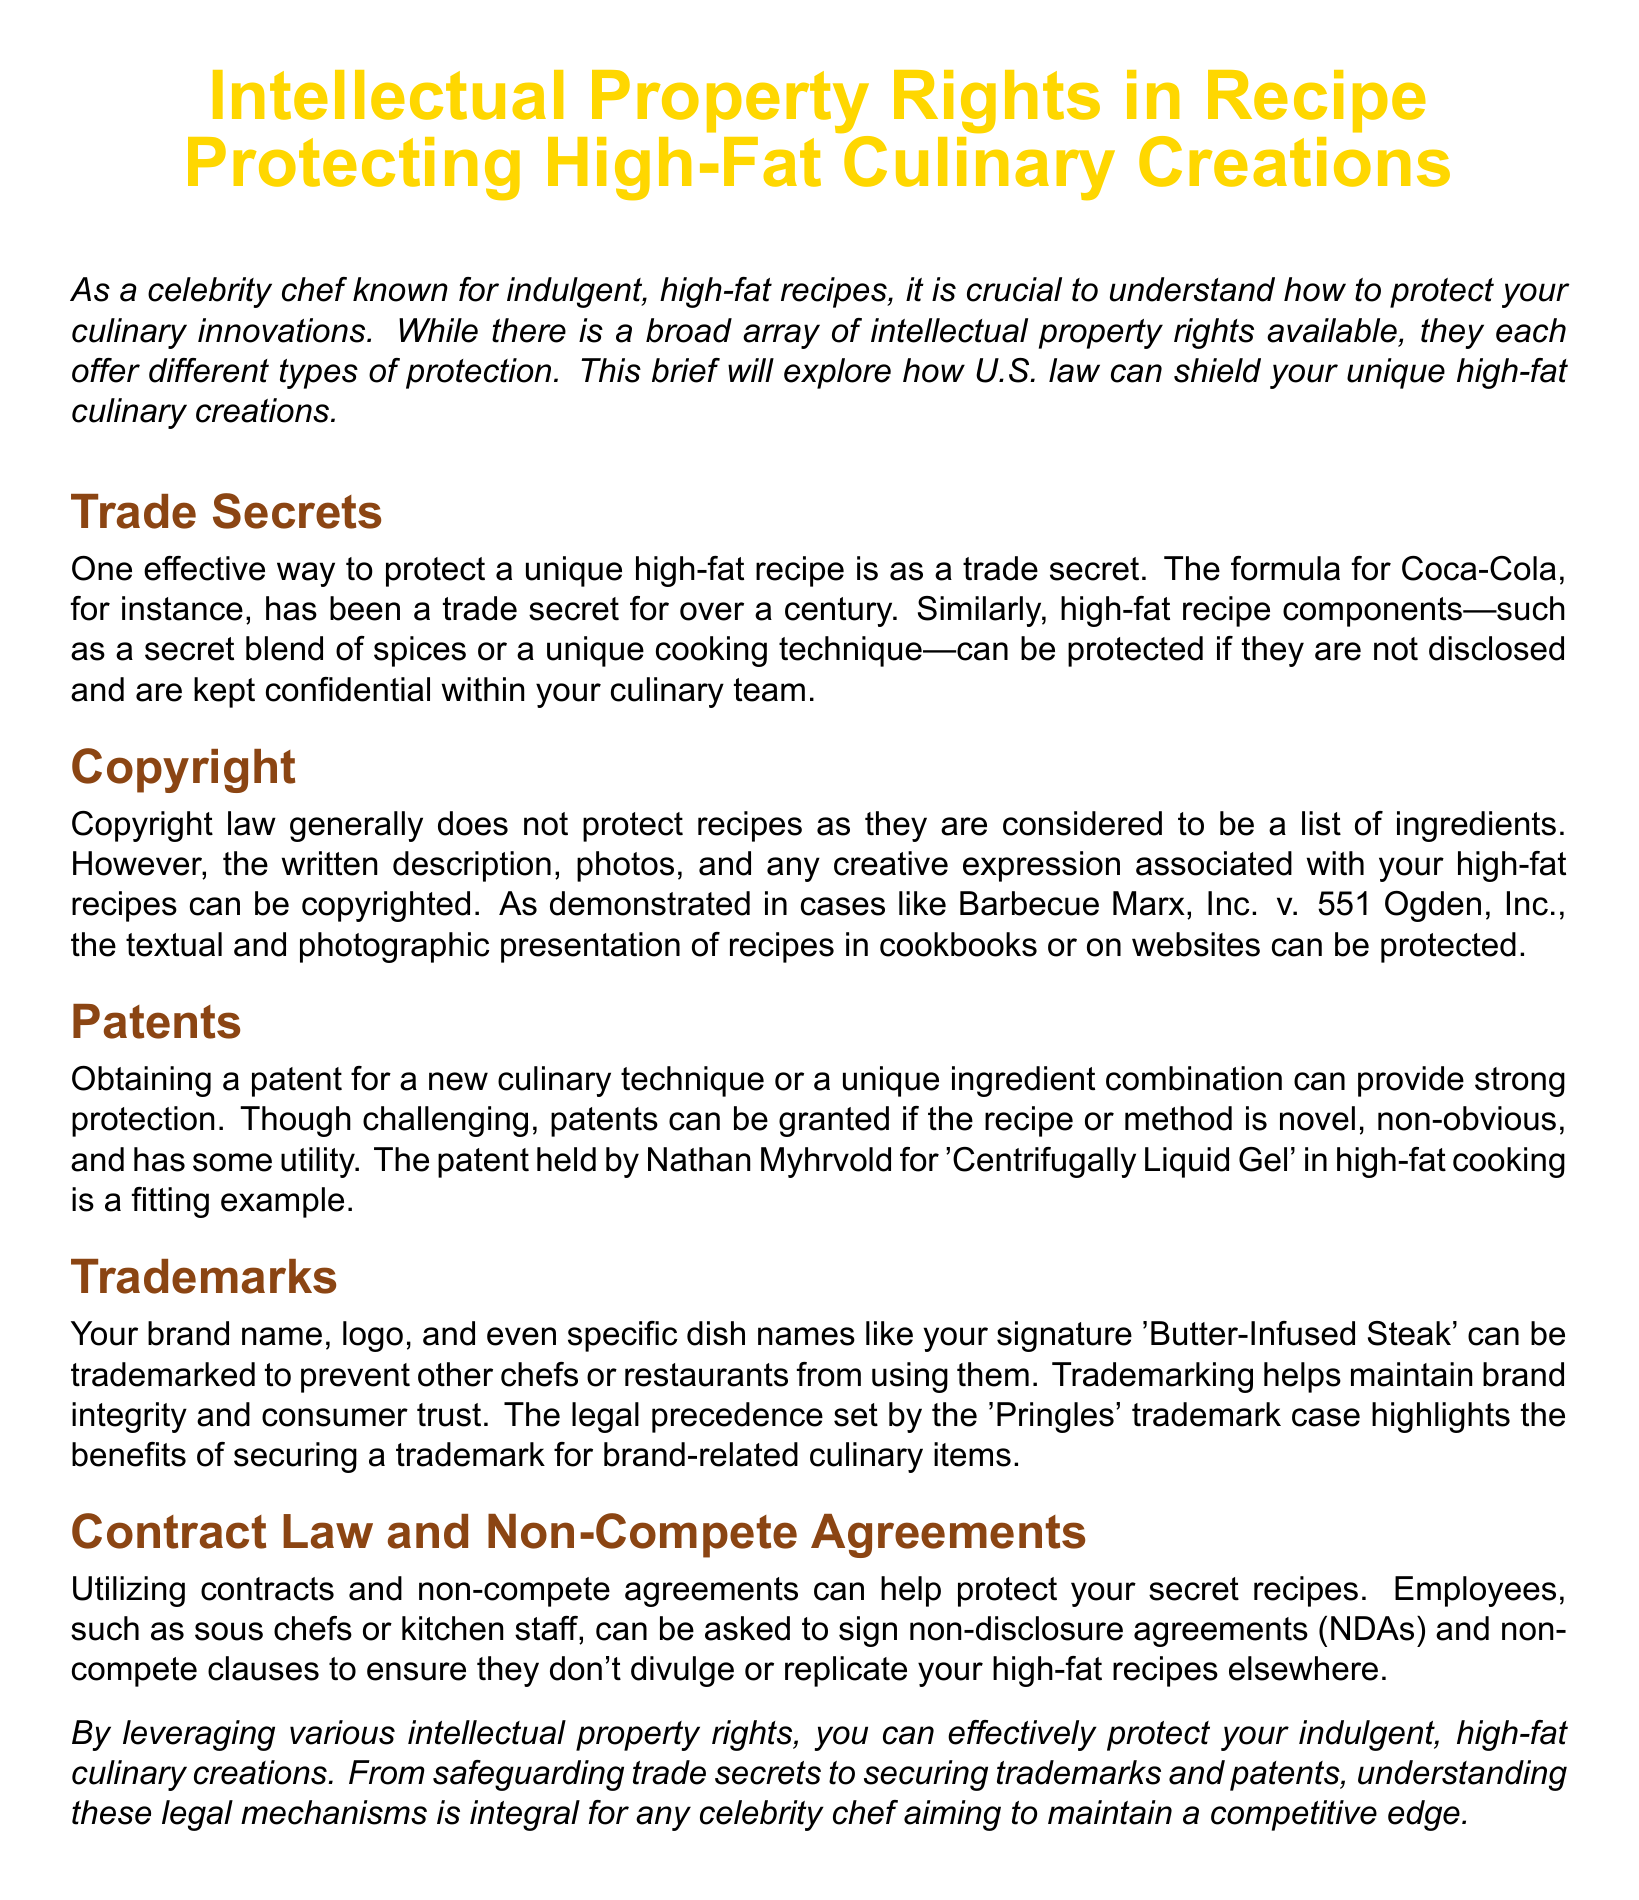What is one way to protect a unique high-fat recipe? The document mentions that one effective way is to protect it as a trade secret, which involves keeping the recipe confidential.
Answer: trade secret What legal case is cited regarding copyright protection? The brief references the case Barbecue Marx, Inc. v. 551 Ogden, Inc. to illustrate how recipe presentation can be protected.
Answer: Barbecue Marx, Inc. v. 551 Ogden, Inc What must a recipe or method be in order to qualify for a patent? It must be novel, non-obvious, and have some utility according to the document.
Answer: novel, non-obvious, utility What can be trademarked according to the brief? The document states that brand names, logos, and specific dish names can be trademarked.
Answer: brand names, logos, dish names What is the purpose of utilizing contracts and non-compete agreements? The primary purpose is to protect secret recipes by ensuring employees do not disclose or replicate them.
Answer: protect secret recipes How long has the formula for Coca-Cola been a trade secret? The document mentions that it has been a trade secret for over a century.
Answer: over a century Which culinary technique related to high-fat cooking is mentioned as an example of a patent? The technique cited in the document is 'Centrifugally Liquid Gel' held by Nathan Myhrvold.
Answer: Centrifugally Liquid Gel Which color is used for the title in the document? The title of the document is styled in chefgold, a specific RGB color defined within the text.
Answer: chefgold What type of law does the brief largely discuss? The document discusses various aspects pertaining to intellectual property rights.
Answer: intellectual property rights 